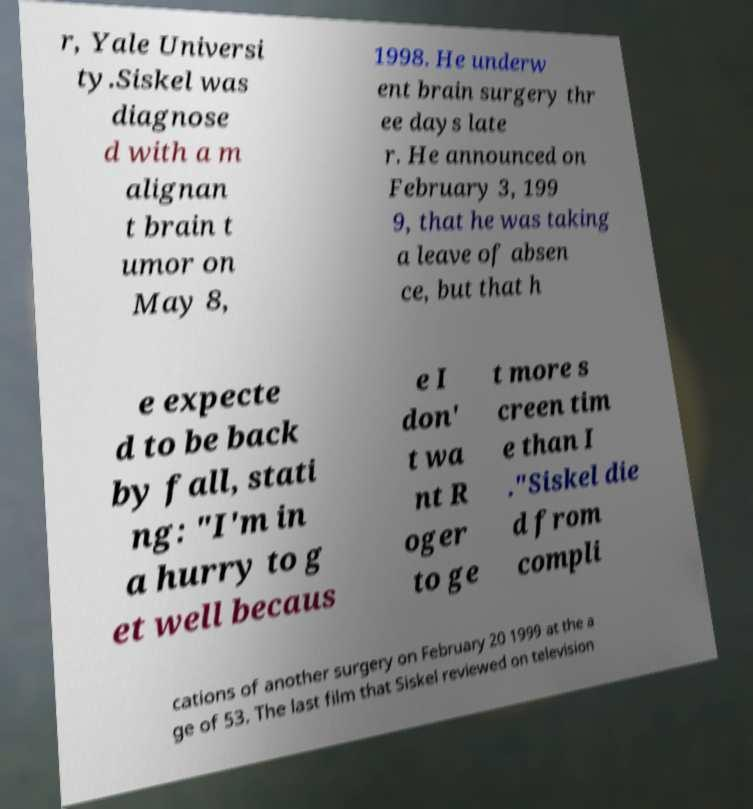Please identify and transcribe the text found in this image. r, Yale Universi ty.Siskel was diagnose d with a m alignan t brain t umor on May 8, 1998. He underw ent brain surgery thr ee days late r. He announced on February 3, 199 9, that he was taking a leave of absen ce, but that h e expecte d to be back by fall, stati ng: "I'm in a hurry to g et well becaus e I don' t wa nt R oger to ge t more s creen tim e than I ."Siskel die d from compli cations of another surgery on February 20 1999 at the a ge of 53. The last film that Siskel reviewed on television 